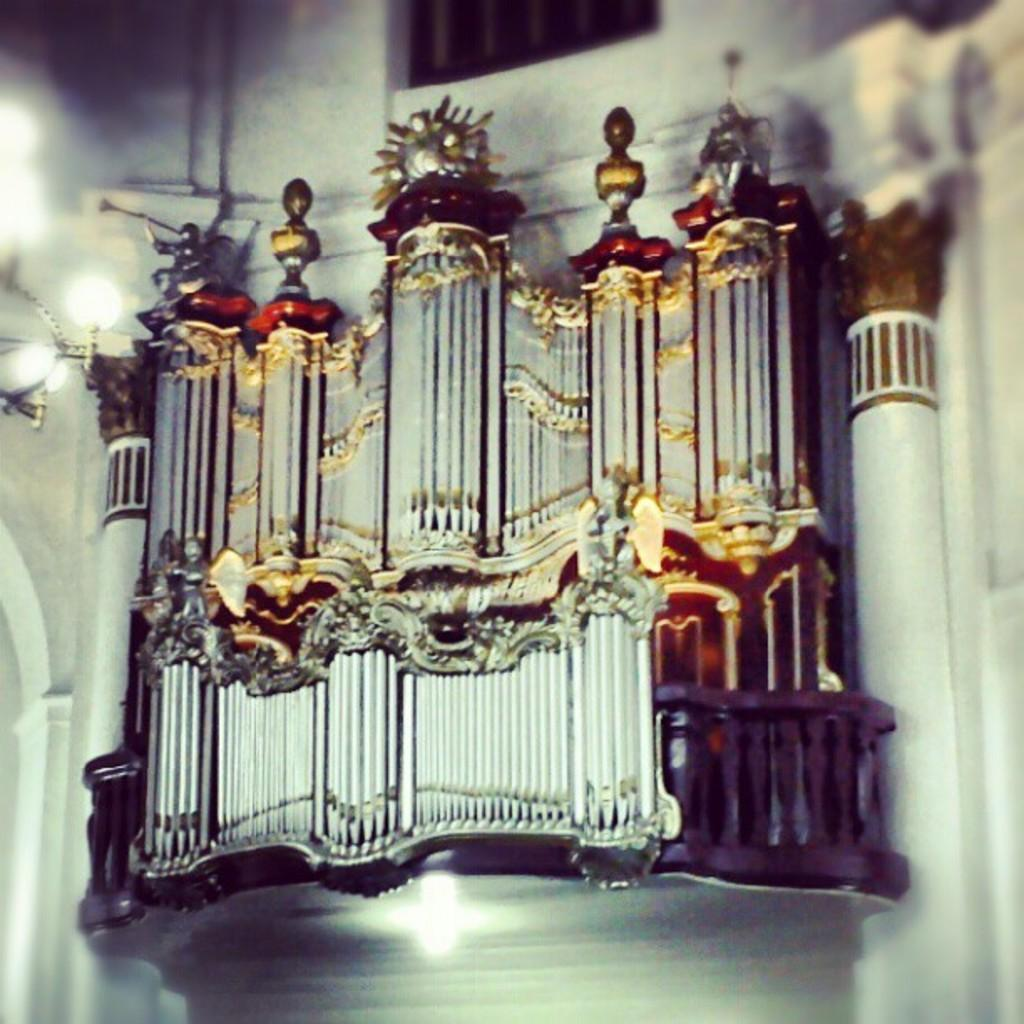What is the main subject of the image? The main subject of the image is a structure that resembles a sculpture. How is the sculpture positioned in the image? The sculpture is attached to a wall in the image. What can be seen in front of the sculpture? There are lights in front of the sculpture. What type of organization is responsible for the sculpture in the image? There is no information about an organization responsible for the sculpture in the image. How many centimeters tall is the sculpture in the image? The provided facts do not include the height of the sculpture, so it cannot be determined from the image. 